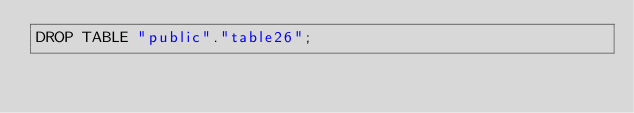<code> <loc_0><loc_0><loc_500><loc_500><_SQL_>DROP TABLE "public"."table26";
</code> 